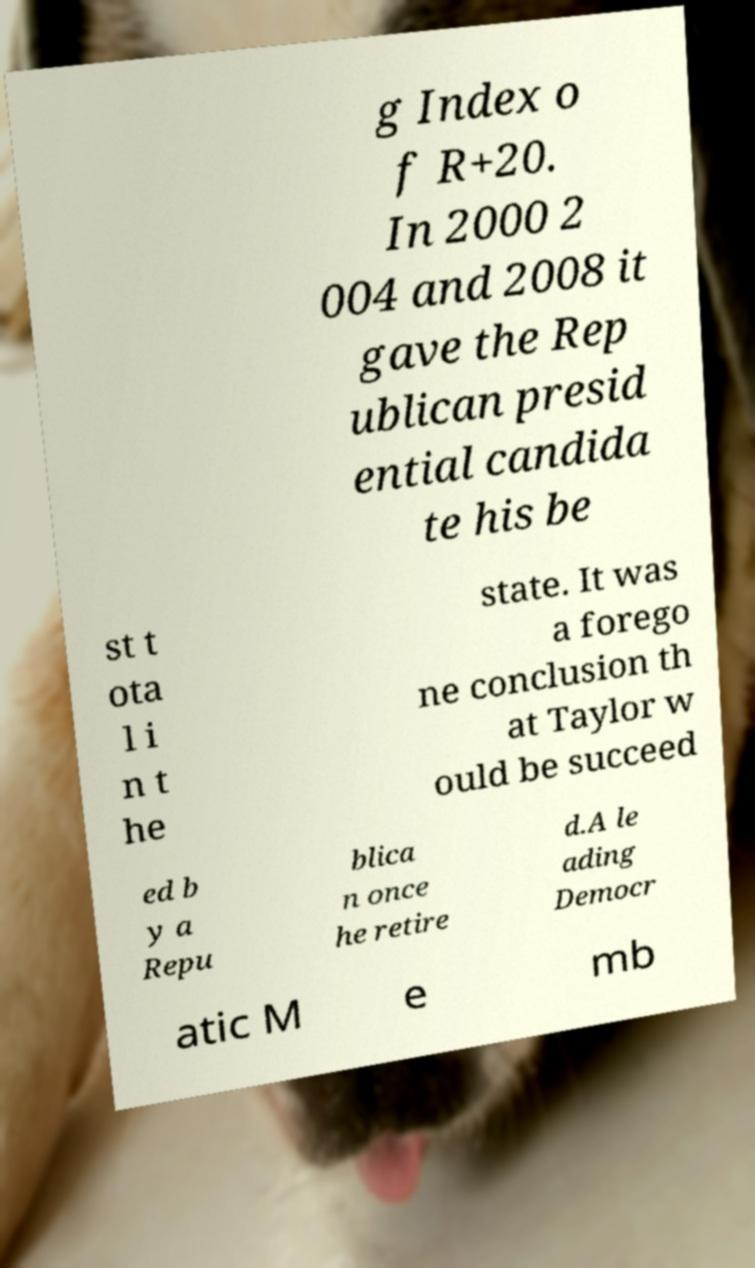I need the written content from this picture converted into text. Can you do that? g Index o f R+20. In 2000 2 004 and 2008 it gave the Rep ublican presid ential candida te his be st t ota l i n t he state. It was a forego ne conclusion th at Taylor w ould be succeed ed b y a Repu blica n once he retire d.A le ading Democr atic M e mb 